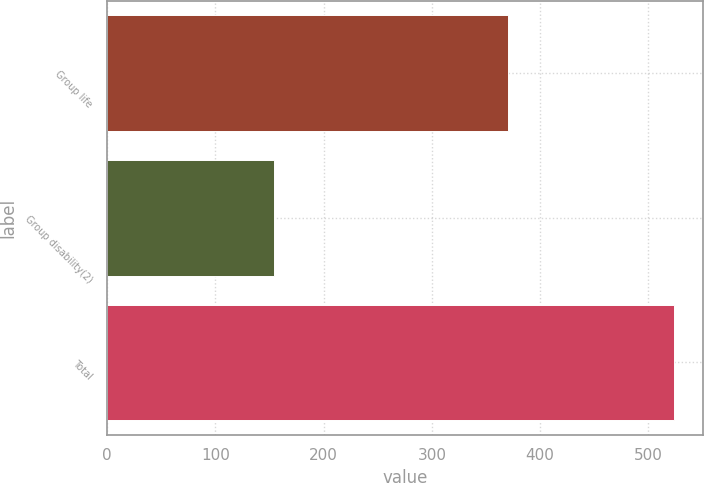<chart> <loc_0><loc_0><loc_500><loc_500><bar_chart><fcel>Group life<fcel>Group disability(2)<fcel>Total<nl><fcel>370<fcel>154<fcel>524<nl></chart> 